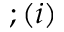<formula> <loc_0><loc_0><loc_500><loc_500>; ( i )</formula> 